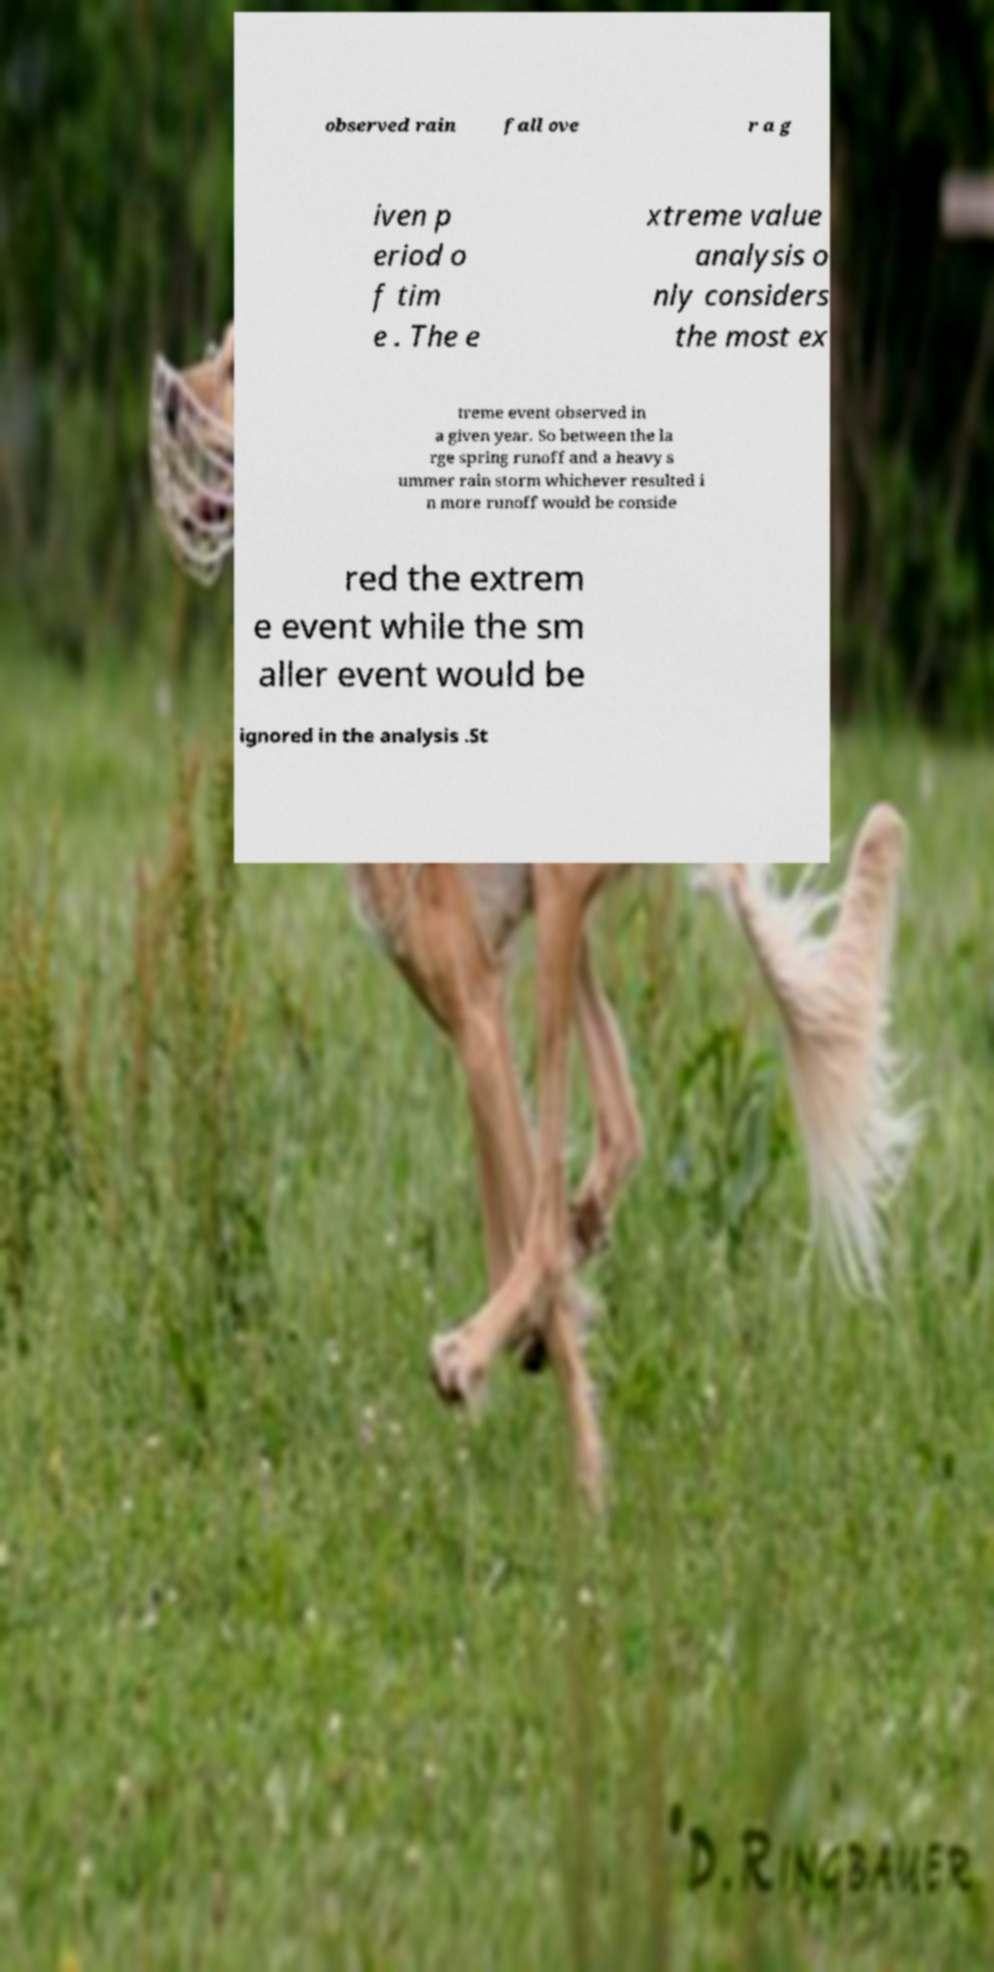Please read and relay the text visible in this image. What does it say? observed rain fall ove r a g iven p eriod o f tim e . The e xtreme value analysis o nly considers the most ex treme event observed in a given year. So between the la rge spring runoff and a heavy s ummer rain storm whichever resulted i n more runoff would be conside red the extrem e event while the sm aller event would be ignored in the analysis .St 